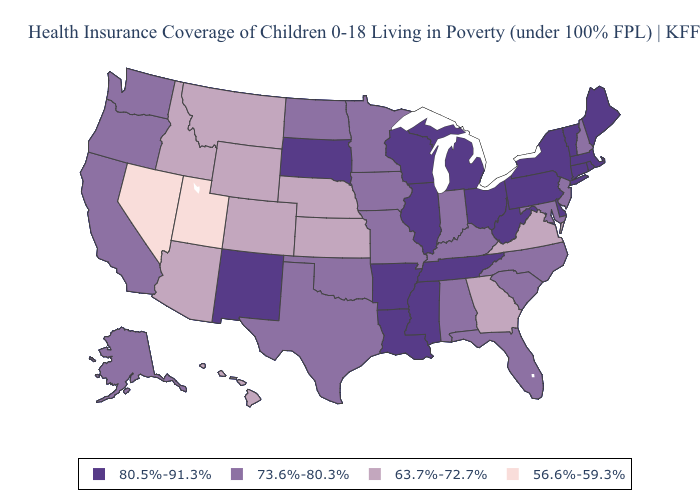Does Alabama have the highest value in the USA?
Quick response, please. No. What is the lowest value in the MidWest?
Give a very brief answer. 63.7%-72.7%. What is the value of Michigan?
Concise answer only. 80.5%-91.3%. What is the highest value in states that border Louisiana?
Keep it brief. 80.5%-91.3%. Name the states that have a value in the range 63.7%-72.7%?
Answer briefly. Arizona, Colorado, Georgia, Hawaii, Idaho, Kansas, Montana, Nebraska, Virginia, Wyoming. What is the value of West Virginia?
Be succinct. 80.5%-91.3%. What is the value of Washington?
Concise answer only. 73.6%-80.3%. What is the value of Oregon?
Give a very brief answer. 73.6%-80.3%. Name the states that have a value in the range 63.7%-72.7%?
Concise answer only. Arizona, Colorado, Georgia, Hawaii, Idaho, Kansas, Montana, Nebraska, Virginia, Wyoming. Among the states that border Nebraska , which have the highest value?
Be succinct. South Dakota. What is the value of Virginia?
Short answer required. 63.7%-72.7%. What is the lowest value in the West?
Keep it brief. 56.6%-59.3%. How many symbols are there in the legend?
Keep it brief. 4. Name the states that have a value in the range 80.5%-91.3%?
Concise answer only. Arkansas, Connecticut, Delaware, Illinois, Louisiana, Maine, Massachusetts, Michigan, Mississippi, New Mexico, New York, Ohio, Pennsylvania, Rhode Island, South Dakota, Tennessee, Vermont, West Virginia, Wisconsin. What is the value of Wyoming?
Write a very short answer. 63.7%-72.7%. 